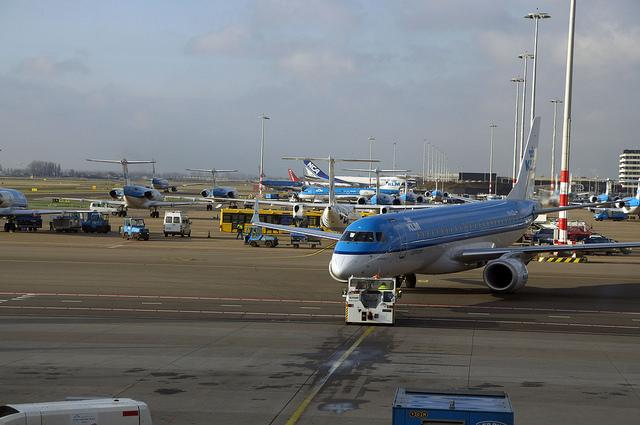What is the circular object under the wing?

Choices:
A) aileron
B) jet engine
C) compartment
D) trash can jet engine 